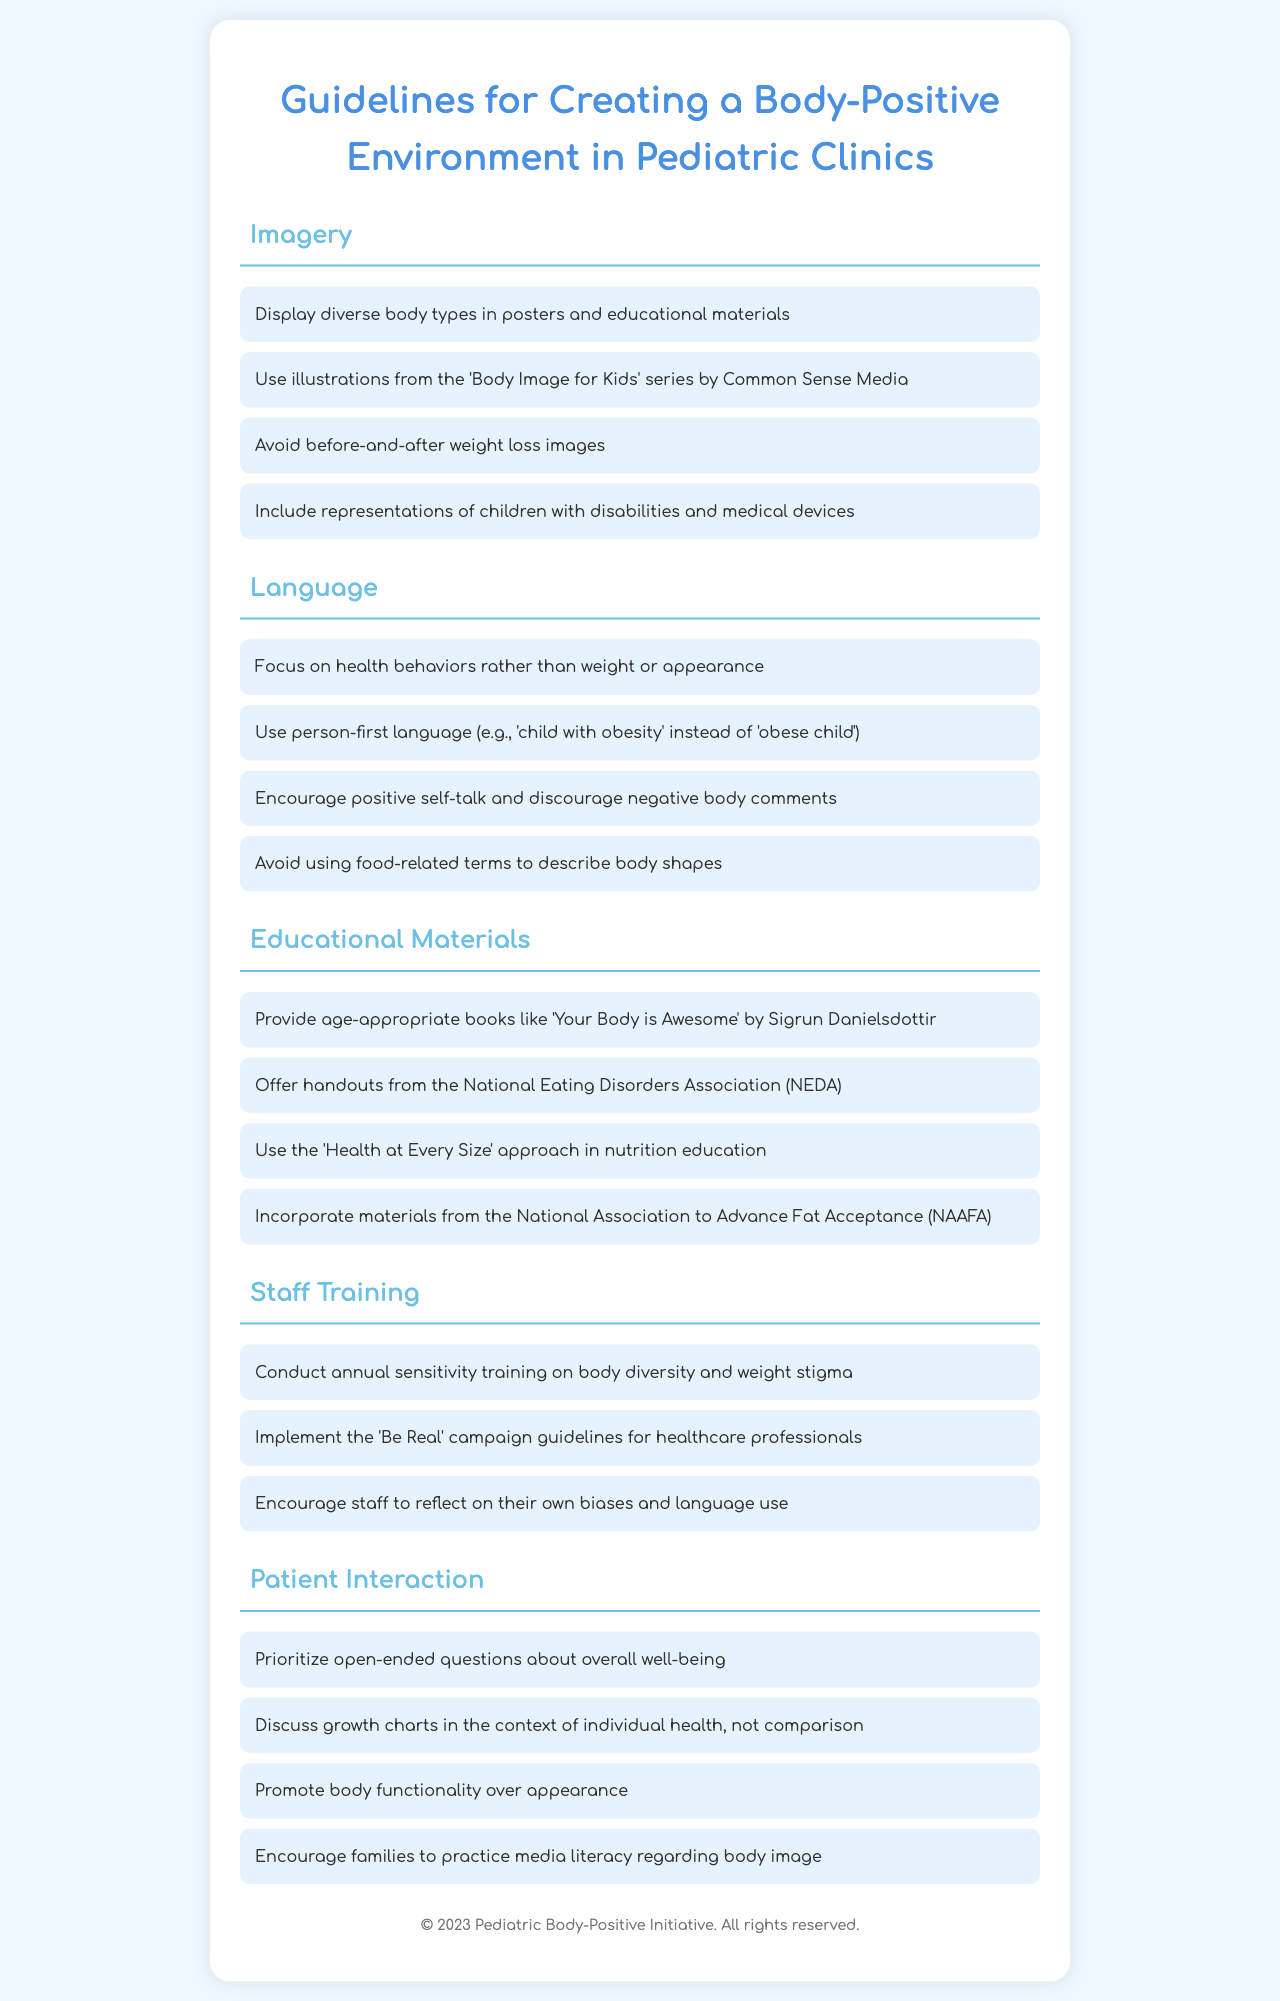What imagery should be displayed? The document suggests displaying diverse body types in posters and educational materials.
Answer: Diverse body types What type of language is encouraged? The focus should be on health behaviors rather than weight or appearance.
Answer: Health behaviors What age-appropriate book is recommended? The document mentions 'Your Body is Awesome' by Sigrun Danielsdottir as a recommended book.
Answer: Your Body is Awesome How often should staff training be conducted? The document specifies that staff training should be conducted annually.
Answer: Annually What approach is advised in nutrition education? The document recommends using the 'Health at Every Size' approach in nutrition education.
Answer: Health at Every Size What should be prioritized in patient interaction? The document advises prioritizing open-ended questions about overall well-being.
Answer: Open-ended questions What campaign guidelines are to be implemented for staff? The document mentions implementing the 'Be Real' campaign guidelines for healthcare professionals.
Answer: Be Real What organization offers handouts according to the document? The National Eating Disorders Association (NEDA) is mentioned as a source of handouts.
Answer: NEDA 